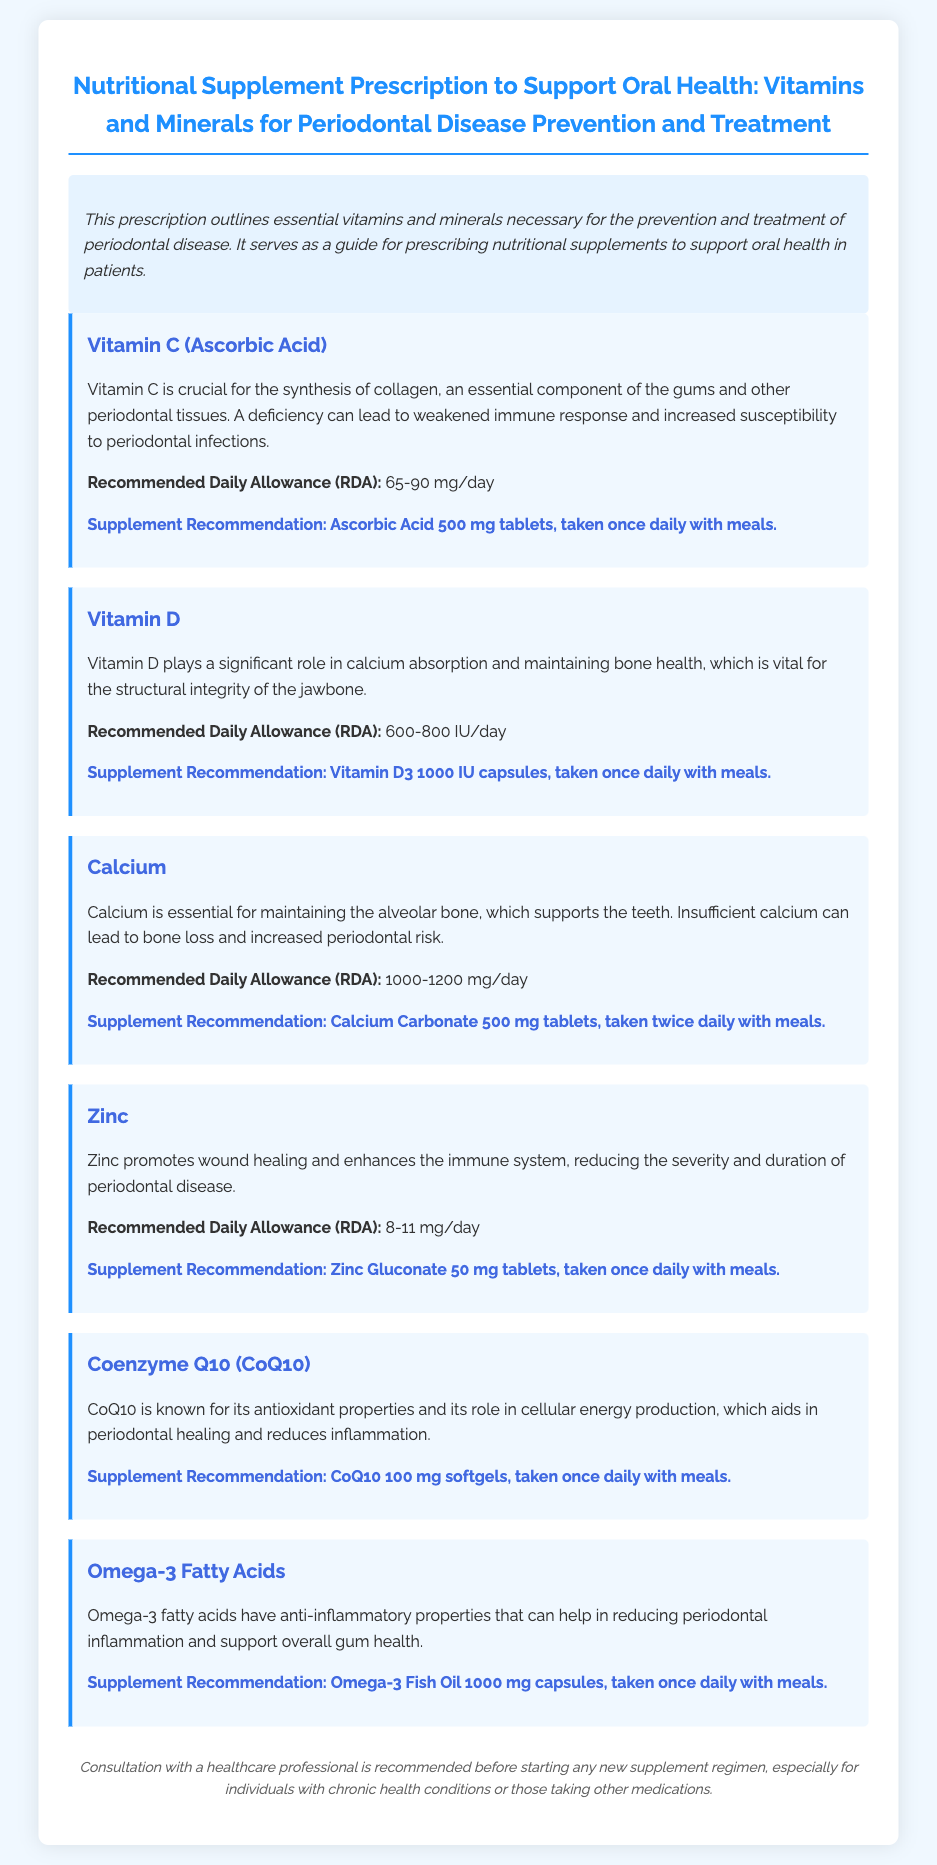What is the title of the document? The title is "Nutritional Supplement Prescription to Support Oral Health: Vitamins and Minerals for Periodontal Disease Prevention and Treatment."
Answer: Nutritional Supplement Prescription to Support Oral Health: Vitamins and Minerals for Periodontal Disease Prevention and Treatment What is the recommended daily allowance of Vitamin C? The recommended daily allowance (RDA) for Vitamin C is found in the supplement section and is stated as 65-90 mg/day.
Answer: 65-90 mg/day What is the supplement recommendation for Calcium? The document specifies supplement recommendations for Calcium, which is Calcium Carbonate 500 mg tablets, taken twice daily with meals.
Answer: Calcium Carbonate 500 mg tablets, taken twice daily with meals What role does Zinc play in oral health? The document mentions that Zinc promotes wound healing and enhances the immune system, which connects to its significance in periodontal health.
Answer: Promotes wound healing What is the daily intake suggestion for Omega-3 Fatty Acids? The daily intake suggestion for Omega-3 Fatty Acids can be found in its supplement section, which states it as taken once daily with meals.
Answer: Taken once daily with meals Why is Vitamin D important according to the document? The document indicates that Vitamin D plays a significant role in calcium absorption and maintaining bone health, which is vital for the jawbone structure.
Answer: Calcium absorption and maintaining bone health What is the supplement form of Coenzyme Q10 recommended? The prescribed form of Coenzyme Q10 can be found in its section where it states CoQ10 100 mg softgels.
Answer: CoQ10 100 mg softgels Which vitamin is essential for collagen synthesis? The document specifies that Vitamin C is crucial for the synthesis of collagen and is essential for the gums and periodontal tissues.
Answer: Vitamin C What important disclaimer is given in the document? The document includes a consultation reminder specifying that individuals should consult with a healthcare professional before starting any new supplement regimen.
Answer: Consultation with a healthcare professional is recommended 